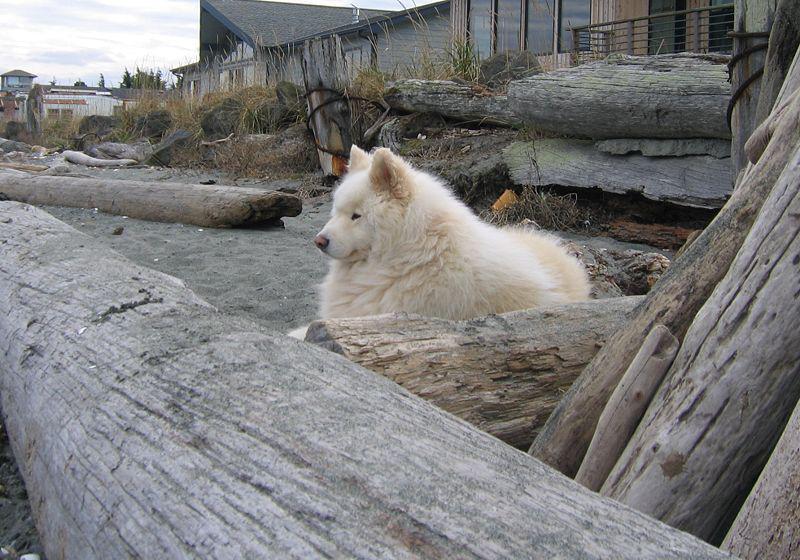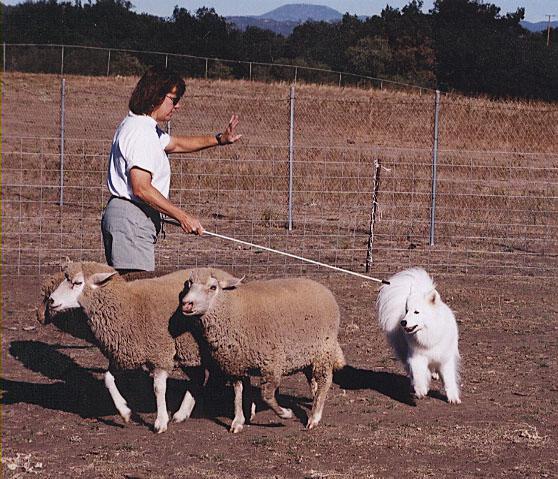The first image is the image on the left, the second image is the image on the right. For the images displayed, is the sentence "A woman holding a stick stands behind multiple woolly sheep and is near a white dog." factually correct? Answer yes or no. Yes. The first image is the image on the left, the second image is the image on the right. For the images displayed, is the sentence "A woman is standing in the field in only one of the images." factually correct? Answer yes or no. Yes. 